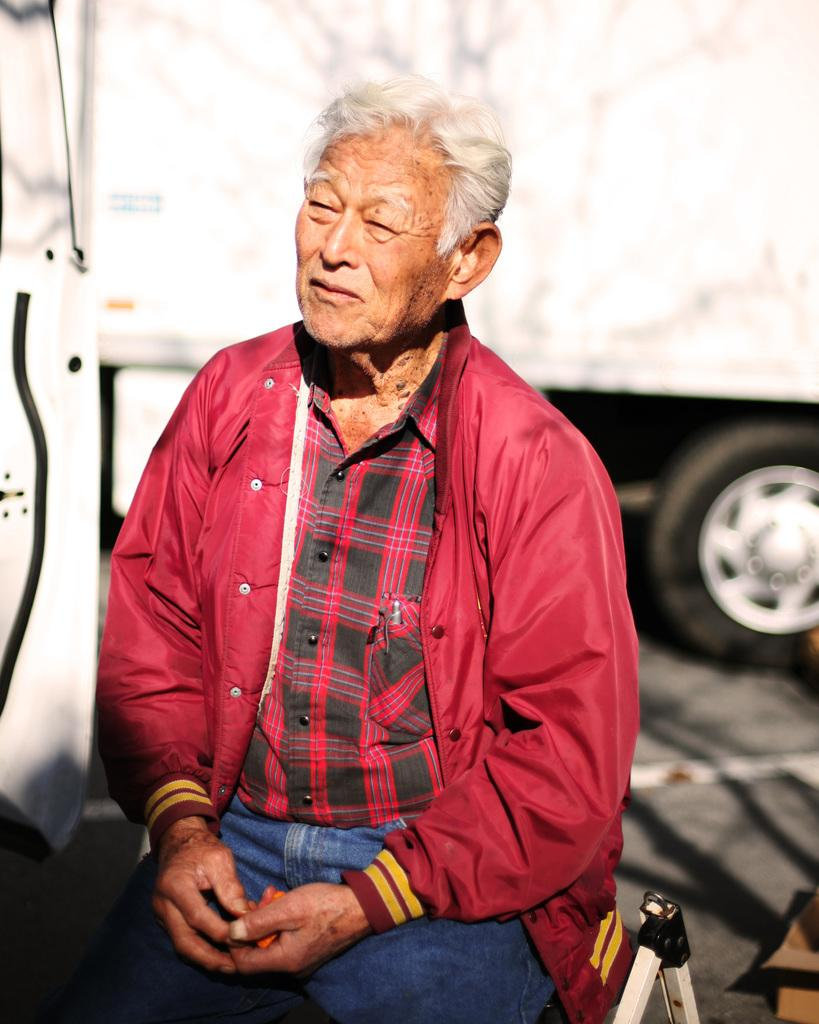What is present in the image? There is a man in the image. Can you describe the background of the image? There is a vehicle in the background of the image. What type of clam is the man holding in the image? There is no clam present in the image; it only features a man and a vehicle in the background. 